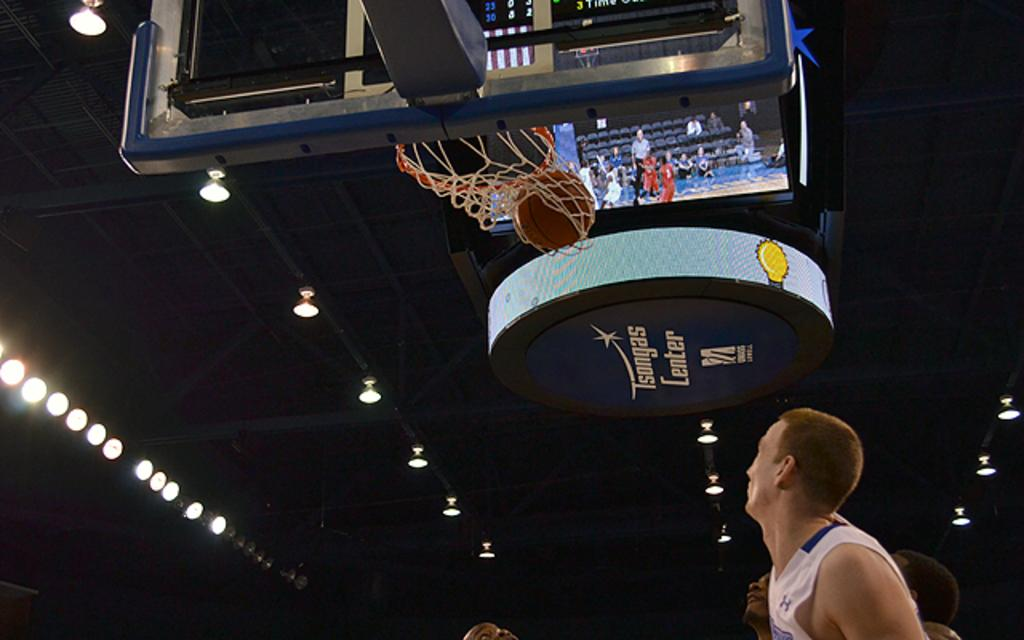<image>
Render a clear and concise summary of the photo. A basketball falls through the hoop a blue sign saying Isongas Lenter in the background. 